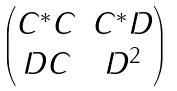<formula> <loc_0><loc_0><loc_500><loc_500>\begin{pmatrix} C ^ { * } C & C ^ { * } D \\ D C & D ^ { 2 } \end{pmatrix}</formula> 